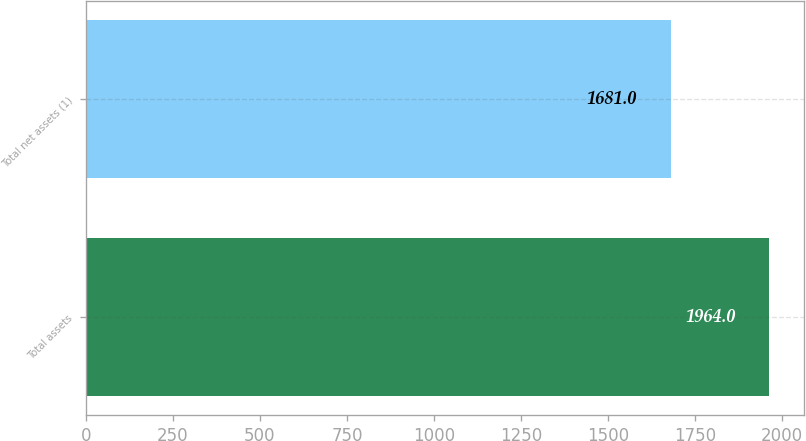Convert chart to OTSL. <chart><loc_0><loc_0><loc_500><loc_500><bar_chart><fcel>Total assets<fcel>Total net assets (1)<nl><fcel>1964<fcel>1681<nl></chart> 